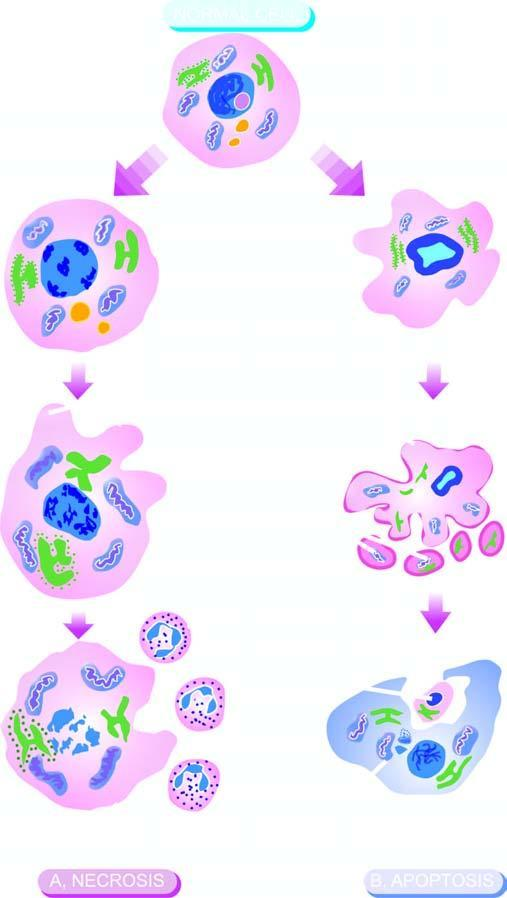what is identified by homogeneous, eosinophilic cytoplasm?
Answer the question using a single word or phrase. Cell necrosis 